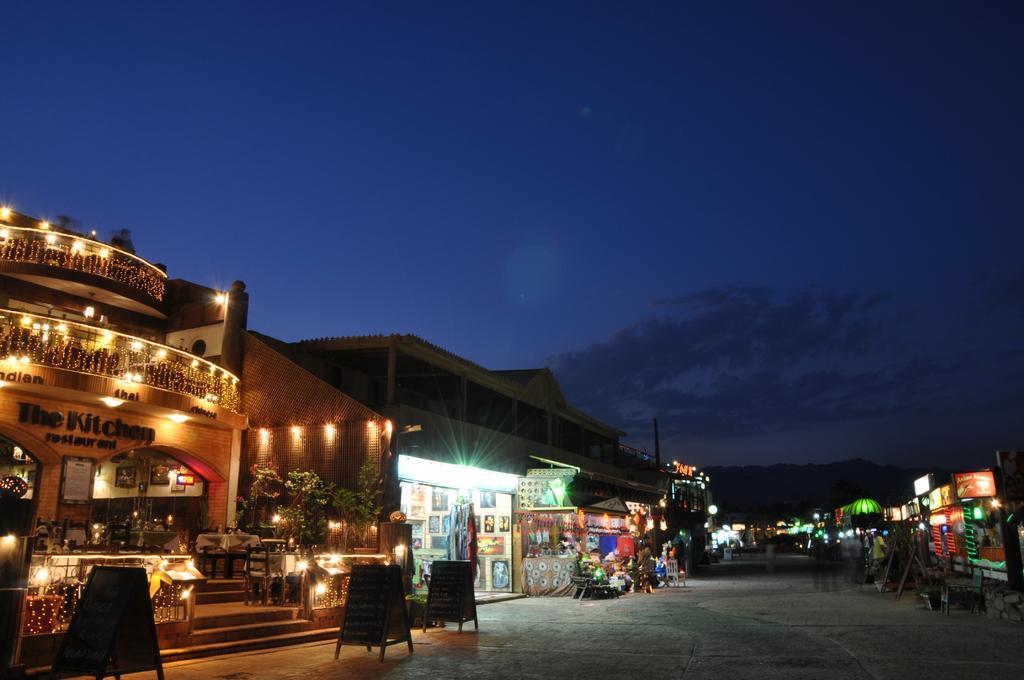Could you give a brief overview of what you see in this image? In this image we can see the shops. And we can see some stalls. And we can see some objects in the shop. And we can see the hill. And we can see the sky. And we can see the wooden boards with some text on it. 